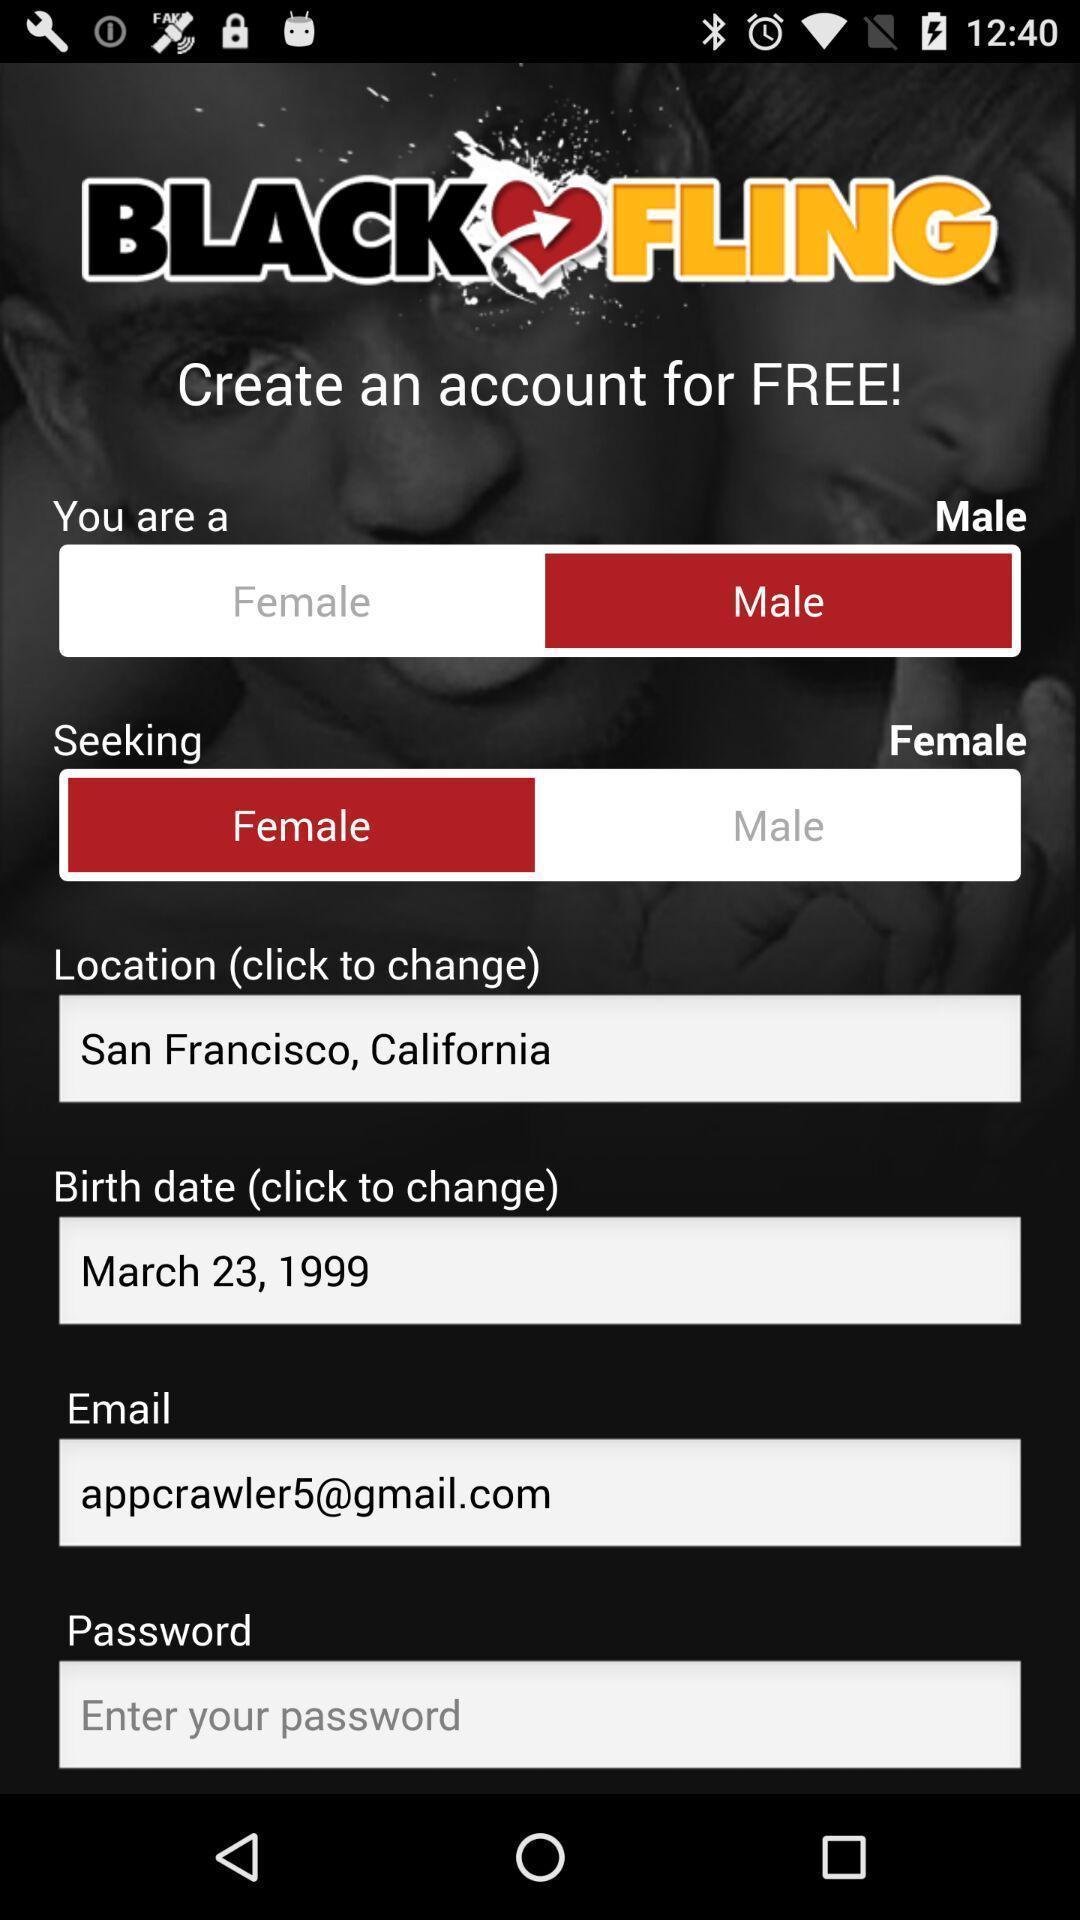Summarize the main components in this picture. Page to create an account for an app. 